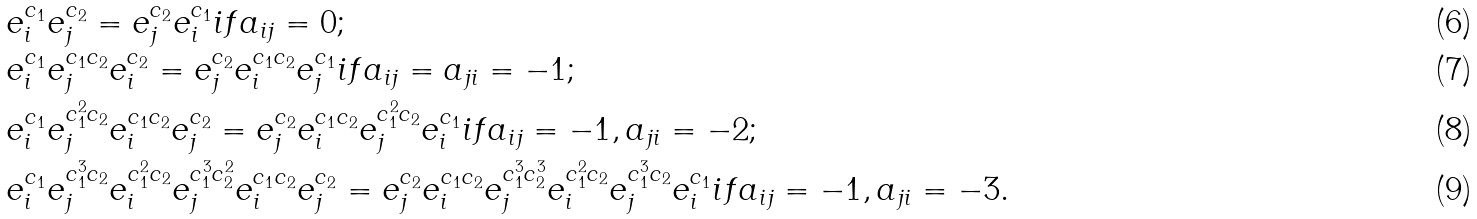Convert formula to latex. <formula><loc_0><loc_0><loc_500><loc_500>& e _ { i } ^ { c _ { 1 } } e _ { j } ^ { c _ { 2 } } = e _ { j } ^ { c _ { 2 } } e _ { i } ^ { c _ { 1 } } i f a _ { i j } = 0 ; \\ & e _ { i } ^ { c _ { 1 } } e _ { j } ^ { c _ { 1 } c _ { 2 } } e _ { i } ^ { c _ { 2 } } = e _ { j } ^ { c _ { 2 } } e _ { i } ^ { c _ { 1 } c _ { 2 } } e _ { j } ^ { c _ { 1 } } i f a _ { i j } = a _ { j i } = - 1 ; \\ & e _ { i } ^ { c _ { 1 } } e _ { j } ^ { c _ { 1 } ^ { 2 } c _ { 2 } } e _ { i } ^ { c _ { 1 } c _ { 2 } } e _ { j } ^ { c _ { 2 } } = e _ { j } ^ { c _ { 2 } } e _ { i } ^ { c _ { 1 } c _ { 2 } } e _ { j } ^ { c _ { 1 } ^ { 2 } c _ { 2 } } e _ { i } ^ { c _ { 1 } } i f a _ { i j } = - 1 , a _ { j i } = - 2 ; \\ & e _ { i } ^ { c _ { 1 } } e _ { j } ^ { c _ { 1 } ^ { 3 } c _ { 2 } } e _ { i } ^ { c _ { 1 } ^ { 2 } c _ { 2 } } e _ { j } ^ { c _ { 1 } ^ { 3 } c _ { 2 } ^ { 2 } } e _ { i } ^ { c _ { 1 } c _ { 2 } } e _ { j } ^ { c _ { 2 } } = e _ { j } ^ { c _ { 2 } } e _ { i } ^ { c _ { 1 } c _ { 2 } } e _ { j } ^ { c _ { 1 } ^ { 3 } c _ { 2 } ^ { 3 } } e _ { i } ^ { c _ { 1 } ^ { 2 } c _ { 2 } } e _ { j } ^ { c _ { 1 } ^ { 3 } c _ { 2 } } e _ { i } ^ { c _ { 1 } } i f a _ { i j } = - 1 , a _ { j i } = - 3 .</formula> 